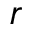<formula> <loc_0><loc_0><loc_500><loc_500>r</formula> 